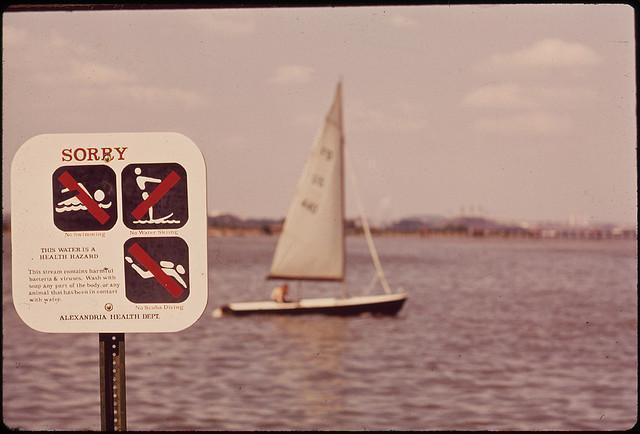How many people are on the boat?
Give a very brief answer. 1. 